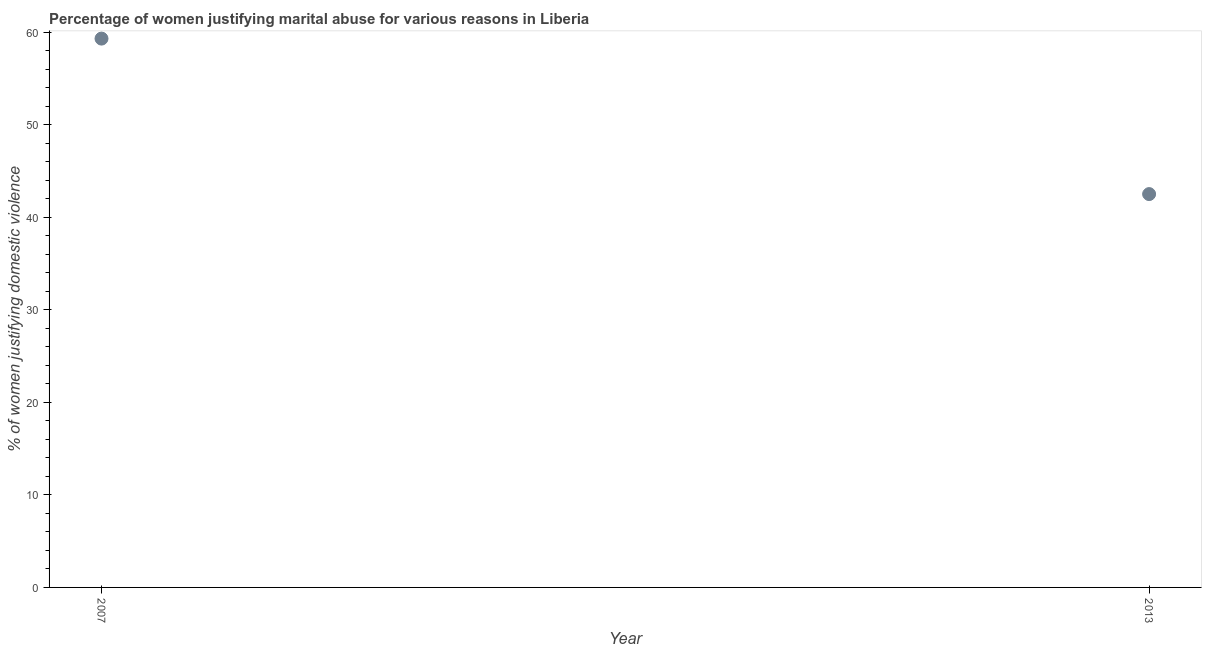What is the percentage of women justifying marital abuse in 2013?
Offer a terse response. 42.5. Across all years, what is the maximum percentage of women justifying marital abuse?
Offer a very short reply. 59.3. Across all years, what is the minimum percentage of women justifying marital abuse?
Provide a short and direct response. 42.5. What is the sum of the percentage of women justifying marital abuse?
Provide a short and direct response. 101.8. What is the difference between the percentage of women justifying marital abuse in 2007 and 2013?
Give a very brief answer. 16.8. What is the average percentage of women justifying marital abuse per year?
Your answer should be compact. 50.9. What is the median percentage of women justifying marital abuse?
Provide a succinct answer. 50.9. What is the ratio of the percentage of women justifying marital abuse in 2007 to that in 2013?
Keep it short and to the point. 1.4. How many years are there in the graph?
Offer a very short reply. 2. Are the values on the major ticks of Y-axis written in scientific E-notation?
Provide a succinct answer. No. What is the title of the graph?
Keep it short and to the point. Percentage of women justifying marital abuse for various reasons in Liberia. What is the label or title of the X-axis?
Keep it short and to the point. Year. What is the label or title of the Y-axis?
Make the answer very short. % of women justifying domestic violence. What is the % of women justifying domestic violence in 2007?
Your answer should be very brief. 59.3. What is the % of women justifying domestic violence in 2013?
Your response must be concise. 42.5. What is the difference between the % of women justifying domestic violence in 2007 and 2013?
Your response must be concise. 16.8. What is the ratio of the % of women justifying domestic violence in 2007 to that in 2013?
Provide a short and direct response. 1.4. 